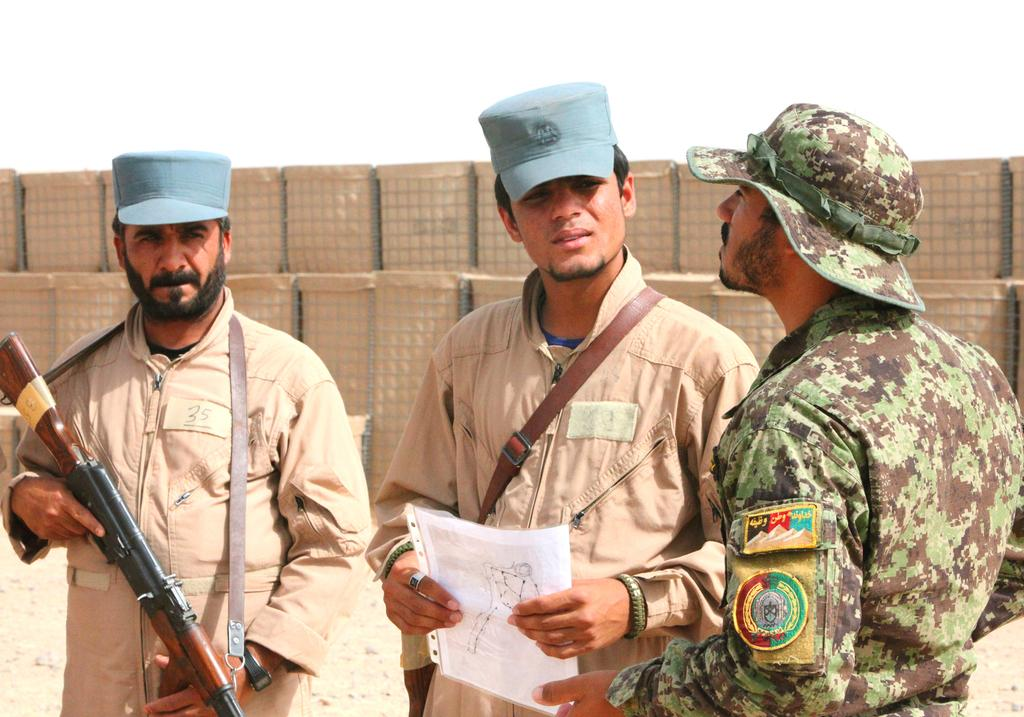How many persons are in the image? There are persons standing in the image. What is one of the persons holding? One of the persons is holding a gun. What can be seen in the background of the image? There are cardboard cartons and the sky visible in the background of the image. What type of pet is visible in the image? There is no pet present in the image. What is the bucket used for in the image? There is no bucket present in the image. 